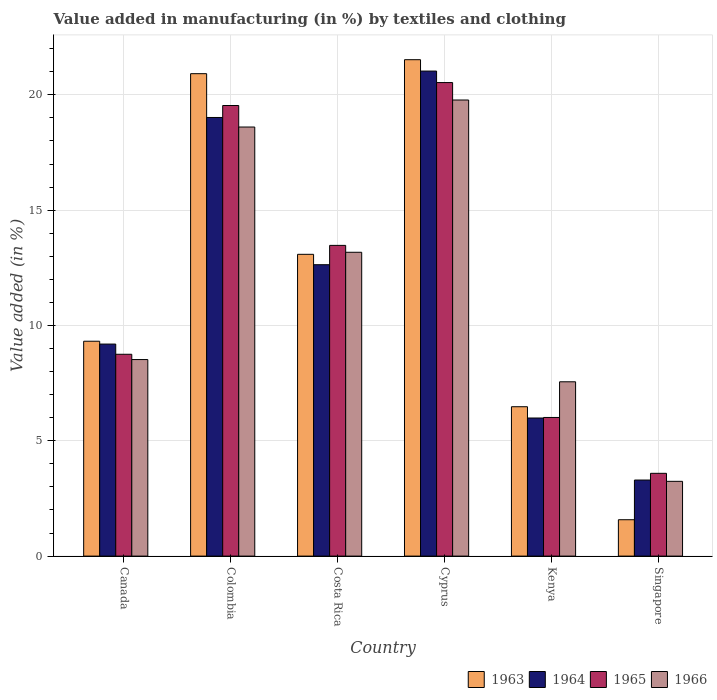Are the number of bars per tick equal to the number of legend labels?
Provide a succinct answer. Yes. In how many cases, is the number of bars for a given country not equal to the number of legend labels?
Your response must be concise. 0. What is the percentage of value added in manufacturing by textiles and clothing in 1964 in Canada?
Ensure brevity in your answer.  9.19. Across all countries, what is the maximum percentage of value added in manufacturing by textiles and clothing in 1964?
Provide a succinct answer. 21.03. Across all countries, what is the minimum percentage of value added in manufacturing by textiles and clothing in 1966?
Give a very brief answer. 3.24. In which country was the percentage of value added in manufacturing by textiles and clothing in 1964 maximum?
Provide a short and direct response. Cyprus. In which country was the percentage of value added in manufacturing by textiles and clothing in 1966 minimum?
Provide a succinct answer. Singapore. What is the total percentage of value added in manufacturing by textiles and clothing in 1963 in the graph?
Ensure brevity in your answer.  72.9. What is the difference between the percentage of value added in manufacturing by textiles and clothing in 1966 in Colombia and that in Costa Rica?
Your answer should be compact. 5.43. What is the difference between the percentage of value added in manufacturing by textiles and clothing in 1965 in Singapore and the percentage of value added in manufacturing by textiles and clothing in 1966 in Cyprus?
Your response must be concise. -16.19. What is the average percentage of value added in manufacturing by textiles and clothing in 1966 per country?
Your response must be concise. 11.81. What is the difference between the percentage of value added in manufacturing by textiles and clothing of/in 1963 and percentage of value added in manufacturing by textiles and clothing of/in 1965 in Canada?
Offer a very short reply. 0.57. What is the ratio of the percentage of value added in manufacturing by textiles and clothing in 1964 in Costa Rica to that in Kenya?
Keep it short and to the point. 2.11. What is the difference between the highest and the second highest percentage of value added in manufacturing by textiles and clothing in 1965?
Ensure brevity in your answer.  -0.99. What is the difference between the highest and the lowest percentage of value added in manufacturing by textiles and clothing in 1964?
Your answer should be very brief. 17.73. Is the sum of the percentage of value added in manufacturing by textiles and clothing in 1966 in Canada and Singapore greater than the maximum percentage of value added in manufacturing by textiles and clothing in 1964 across all countries?
Your answer should be very brief. No. Is it the case that in every country, the sum of the percentage of value added in manufacturing by textiles and clothing in 1963 and percentage of value added in manufacturing by textiles and clothing in 1964 is greater than the sum of percentage of value added in manufacturing by textiles and clothing in 1966 and percentage of value added in manufacturing by textiles and clothing in 1965?
Offer a very short reply. No. What does the 4th bar from the left in Canada represents?
Provide a succinct answer. 1966. What does the 1st bar from the right in Colombia represents?
Provide a short and direct response. 1966. Is it the case that in every country, the sum of the percentage of value added in manufacturing by textiles and clothing in 1966 and percentage of value added in manufacturing by textiles and clothing in 1965 is greater than the percentage of value added in manufacturing by textiles and clothing in 1964?
Keep it short and to the point. Yes. How many bars are there?
Your response must be concise. 24. What is the difference between two consecutive major ticks on the Y-axis?
Your answer should be very brief. 5. Does the graph contain grids?
Your response must be concise. Yes. What is the title of the graph?
Your answer should be compact. Value added in manufacturing (in %) by textiles and clothing. Does "1988" appear as one of the legend labels in the graph?
Offer a very short reply. No. What is the label or title of the X-axis?
Provide a short and direct response. Country. What is the label or title of the Y-axis?
Offer a terse response. Value added (in %). What is the Value added (in %) of 1963 in Canada?
Your answer should be compact. 9.32. What is the Value added (in %) of 1964 in Canada?
Ensure brevity in your answer.  9.19. What is the Value added (in %) of 1965 in Canada?
Give a very brief answer. 8.75. What is the Value added (in %) in 1966 in Canada?
Ensure brevity in your answer.  8.52. What is the Value added (in %) in 1963 in Colombia?
Make the answer very short. 20.92. What is the Value added (in %) in 1964 in Colombia?
Give a very brief answer. 19.02. What is the Value added (in %) in 1965 in Colombia?
Your response must be concise. 19.54. What is the Value added (in %) of 1966 in Colombia?
Give a very brief answer. 18.6. What is the Value added (in %) of 1963 in Costa Rica?
Your answer should be very brief. 13.08. What is the Value added (in %) in 1964 in Costa Rica?
Ensure brevity in your answer.  12.63. What is the Value added (in %) in 1965 in Costa Rica?
Provide a succinct answer. 13.47. What is the Value added (in %) in 1966 in Costa Rica?
Ensure brevity in your answer.  13.17. What is the Value added (in %) in 1963 in Cyprus?
Give a very brief answer. 21.52. What is the Value added (in %) in 1964 in Cyprus?
Give a very brief answer. 21.03. What is the Value added (in %) of 1965 in Cyprus?
Your answer should be very brief. 20.53. What is the Value added (in %) of 1966 in Cyprus?
Offer a terse response. 19.78. What is the Value added (in %) in 1963 in Kenya?
Keep it short and to the point. 6.48. What is the Value added (in %) of 1964 in Kenya?
Ensure brevity in your answer.  5.99. What is the Value added (in %) in 1965 in Kenya?
Offer a very short reply. 6.01. What is the Value added (in %) of 1966 in Kenya?
Offer a terse response. 7.56. What is the Value added (in %) of 1963 in Singapore?
Your answer should be very brief. 1.58. What is the Value added (in %) of 1964 in Singapore?
Offer a terse response. 3.3. What is the Value added (in %) of 1965 in Singapore?
Give a very brief answer. 3.59. What is the Value added (in %) of 1966 in Singapore?
Give a very brief answer. 3.24. Across all countries, what is the maximum Value added (in %) in 1963?
Make the answer very short. 21.52. Across all countries, what is the maximum Value added (in %) of 1964?
Offer a terse response. 21.03. Across all countries, what is the maximum Value added (in %) in 1965?
Provide a succinct answer. 20.53. Across all countries, what is the maximum Value added (in %) of 1966?
Your response must be concise. 19.78. Across all countries, what is the minimum Value added (in %) of 1963?
Make the answer very short. 1.58. Across all countries, what is the minimum Value added (in %) of 1964?
Offer a terse response. 3.3. Across all countries, what is the minimum Value added (in %) of 1965?
Give a very brief answer. 3.59. Across all countries, what is the minimum Value added (in %) of 1966?
Your response must be concise. 3.24. What is the total Value added (in %) of 1963 in the graph?
Make the answer very short. 72.9. What is the total Value added (in %) in 1964 in the graph?
Make the answer very short. 71.16. What is the total Value added (in %) of 1965 in the graph?
Give a very brief answer. 71.89. What is the total Value added (in %) of 1966 in the graph?
Provide a succinct answer. 70.87. What is the difference between the Value added (in %) of 1963 in Canada and that in Colombia?
Ensure brevity in your answer.  -11.6. What is the difference between the Value added (in %) of 1964 in Canada and that in Colombia?
Provide a succinct answer. -9.82. What is the difference between the Value added (in %) of 1965 in Canada and that in Colombia?
Provide a succinct answer. -10.79. What is the difference between the Value added (in %) of 1966 in Canada and that in Colombia?
Make the answer very short. -10.08. What is the difference between the Value added (in %) of 1963 in Canada and that in Costa Rica?
Keep it short and to the point. -3.77. What is the difference between the Value added (in %) in 1964 in Canada and that in Costa Rica?
Offer a terse response. -3.44. What is the difference between the Value added (in %) in 1965 in Canada and that in Costa Rica?
Keep it short and to the point. -4.72. What is the difference between the Value added (in %) in 1966 in Canada and that in Costa Rica?
Provide a short and direct response. -4.65. What is the difference between the Value added (in %) of 1963 in Canada and that in Cyprus?
Provide a succinct answer. -12.21. What is the difference between the Value added (in %) of 1964 in Canada and that in Cyprus?
Make the answer very short. -11.84. What is the difference between the Value added (in %) of 1965 in Canada and that in Cyprus?
Make the answer very short. -11.78. What is the difference between the Value added (in %) in 1966 in Canada and that in Cyprus?
Keep it short and to the point. -11.25. What is the difference between the Value added (in %) in 1963 in Canada and that in Kenya?
Provide a succinct answer. 2.84. What is the difference between the Value added (in %) in 1964 in Canada and that in Kenya?
Your answer should be compact. 3.21. What is the difference between the Value added (in %) of 1965 in Canada and that in Kenya?
Give a very brief answer. 2.74. What is the difference between the Value added (in %) of 1966 in Canada and that in Kenya?
Provide a succinct answer. 0.96. What is the difference between the Value added (in %) of 1963 in Canada and that in Singapore?
Provide a succinct answer. 7.74. What is the difference between the Value added (in %) in 1964 in Canada and that in Singapore?
Make the answer very short. 5.9. What is the difference between the Value added (in %) in 1965 in Canada and that in Singapore?
Provide a succinct answer. 5.16. What is the difference between the Value added (in %) in 1966 in Canada and that in Singapore?
Make the answer very short. 5.28. What is the difference between the Value added (in %) in 1963 in Colombia and that in Costa Rica?
Make the answer very short. 7.83. What is the difference between the Value added (in %) of 1964 in Colombia and that in Costa Rica?
Give a very brief answer. 6.38. What is the difference between the Value added (in %) in 1965 in Colombia and that in Costa Rica?
Provide a succinct answer. 6.06. What is the difference between the Value added (in %) of 1966 in Colombia and that in Costa Rica?
Your response must be concise. 5.43. What is the difference between the Value added (in %) in 1963 in Colombia and that in Cyprus?
Provide a succinct answer. -0.61. What is the difference between the Value added (in %) in 1964 in Colombia and that in Cyprus?
Provide a short and direct response. -2.01. What is the difference between the Value added (in %) of 1965 in Colombia and that in Cyprus?
Make the answer very short. -0.99. What is the difference between the Value added (in %) in 1966 in Colombia and that in Cyprus?
Keep it short and to the point. -1.17. What is the difference between the Value added (in %) in 1963 in Colombia and that in Kenya?
Give a very brief answer. 14.44. What is the difference between the Value added (in %) in 1964 in Colombia and that in Kenya?
Make the answer very short. 13.03. What is the difference between the Value added (in %) of 1965 in Colombia and that in Kenya?
Offer a terse response. 13.53. What is the difference between the Value added (in %) in 1966 in Colombia and that in Kenya?
Make the answer very short. 11.05. What is the difference between the Value added (in %) of 1963 in Colombia and that in Singapore?
Keep it short and to the point. 19.34. What is the difference between the Value added (in %) in 1964 in Colombia and that in Singapore?
Offer a very short reply. 15.72. What is the difference between the Value added (in %) in 1965 in Colombia and that in Singapore?
Your response must be concise. 15.95. What is the difference between the Value added (in %) in 1966 in Colombia and that in Singapore?
Your answer should be compact. 15.36. What is the difference between the Value added (in %) of 1963 in Costa Rica and that in Cyprus?
Offer a terse response. -8.44. What is the difference between the Value added (in %) in 1964 in Costa Rica and that in Cyprus?
Offer a very short reply. -8.4. What is the difference between the Value added (in %) in 1965 in Costa Rica and that in Cyprus?
Make the answer very short. -7.06. What is the difference between the Value added (in %) of 1966 in Costa Rica and that in Cyprus?
Offer a very short reply. -6.6. What is the difference between the Value added (in %) in 1963 in Costa Rica and that in Kenya?
Offer a terse response. 6.61. What is the difference between the Value added (in %) of 1964 in Costa Rica and that in Kenya?
Your answer should be compact. 6.65. What is the difference between the Value added (in %) of 1965 in Costa Rica and that in Kenya?
Give a very brief answer. 7.46. What is the difference between the Value added (in %) in 1966 in Costa Rica and that in Kenya?
Provide a succinct answer. 5.62. What is the difference between the Value added (in %) of 1963 in Costa Rica and that in Singapore?
Make the answer very short. 11.51. What is the difference between the Value added (in %) of 1964 in Costa Rica and that in Singapore?
Give a very brief answer. 9.34. What is the difference between the Value added (in %) of 1965 in Costa Rica and that in Singapore?
Your answer should be very brief. 9.88. What is the difference between the Value added (in %) of 1966 in Costa Rica and that in Singapore?
Provide a succinct answer. 9.93. What is the difference between the Value added (in %) in 1963 in Cyprus and that in Kenya?
Keep it short and to the point. 15.05. What is the difference between the Value added (in %) in 1964 in Cyprus and that in Kenya?
Your response must be concise. 15.04. What is the difference between the Value added (in %) in 1965 in Cyprus and that in Kenya?
Keep it short and to the point. 14.52. What is the difference between the Value added (in %) in 1966 in Cyprus and that in Kenya?
Make the answer very short. 12.22. What is the difference between the Value added (in %) in 1963 in Cyprus and that in Singapore?
Ensure brevity in your answer.  19.95. What is the difference between the Value added (in %) of 1964 in Cyprus and that in Singapore?
Keep it short and to the point. 17.73. What is the difference between the Value added (in %) in 1965 in Cyprus and that in Singapore?
Offer a very short reply. 16.94. What is the difference between the Value added (in %) in 1966 in Cyprus and that in Singapore?
Give a very brief answer. 16.53. What is the difference between the Value added (in %) of 1963 in Kenya and that in Singapore?
Give a very brief answer. 4.9. What is the difference between the Value added (in %) in 1964 in Kenya and that in Singapore?
Your response must be concise. 2.69. What is the difference between the Value added (in %) of 1965 in Kenya and that in Singapore?
Your response must be concise. 2.42. What is the difference between the Value added (in %) of 1966 in Kenya and that in Singapore?
Give a very brief answer. 4.32. What is the difference between the Value added (in %) in 1963 in Canada and the Value added (in %) in 1964 in Colombia?
Make the answer very short. -9.7. What is the difference between the Value added (in %) in 1963 in Canada and the Value added (in %) in 1965 in Colombia?
Offer a terse response. -10.22. What is the difference between the Value added (in %) in 1963 in Canada and the Value added (in %) in 1966 in Colombia?
Keep it short and to the point. -9.29. What is the difference between the Value added (in %) in 1964 in Canada and the Value added (in %) in 1965 in Colombia?
Your answer should be very brief. -10.34. What is the difference between the Value added (in %) in 1964 in Canada and the Value added (in %) in 1966 in Colombia?
Offer a very short reply. -9.41. What is the difference between the Value added (in %) of 1965 in Canada and the Value added (in %) of 1966 in Colombia?
Give a very brief answer. -9.85. What is the difference between the Value added (in %) of 1963 in Canada and the Value added (in %) of 1964 in Costa Rica?
Give a very brief answer. -3.32. What is the difference between the Value added (in %) in 1963 in Canada and the Value added (in %) in 1965 in Costa Rica?
Your response must be concise. -4.16. What is the difference between the Value added (in %) of 1963 in Canada and the Value added (in %) of 1966 in Costa Rica?
Your answer should be compact. -3.86. What is the difference between the Value added (in %) of 1964 in Canada and the Value added (in %) of 1965 in Costa Rica?
Provide a succinct answer. -4.28. What is the difference between the Value added (in %) of 1964 in Canada and the Value added (in %) of 1966 in Costa Rica?
Offer a very short reply. -3.98. What is the difference between the Value added (in %) of 1965 in Canada and the Value added (in %) of 1966 in Costa Rica?
Offer a very short reply. -4.42. What is the difference between the Value added (in %) of 1963 in Canada and the Value added (in %) of 1964 in Cyprus?
Provide a short and direct response. -11.71. What is the difference between the Value added (in %) in 1963 in Canada and the Value added (in %) in 1965 in Cyprus?
Offer a terse response. -11.21. What is the difference between the Value added (in %) in 1963 in Canada and the Value added (in %) in 1966 in Cyprus?
Provide a succinct answer. -10.46. What is the difference between the Value added (in %) of 1964 in Canada and the Value added (in %) of 1965 in Cyprus?
Offer a very short reply. -11.34. What is the difference between the Value added (in %) of 1964 in Canada and the Value added (in %) of 1966 in Cyprus?
Offer a terse response. -10.58. What is the difference between the Value added (in %) of 1965 in Canada and the Value added (in %) of 1966 in Cyprus?
Make the answer very short. -11.02. What is the difference between the Value added (in %) of 1963 in Canada and the Value added (in %) of 1964 in Kenya?
Provide a succinct answer. 3.33. What is the difference between the Value added (in %) in 1963 in Canada and the Value added (in %) in 1965 in Kenya?
Offer a terse response. 3.31. What is the difference between the Value added (in %) of 1963 in Canada and the Value added (in %) of 1966 in Kenya?
Your answer should be very brief. 1.76. What is the difference between the Value added (in %) of 1964 in Canada and the Value added (in %) of 1965 in Kenya?
Your answer should be compact. 3.18. What is the difference between the Value added (in %) of 1964 in Canada and the Value added (in %) of 1966 in Kenya?
Provide a short and direct response. 1.64. What is the difference between the Value added (in %) of 1965 in Canada and the Value added (in %) of 1966 in Kenya?
Your response must be concise. 1.19. What is the difference between the Value added (in %) in 1963 in Canada and the Value added (in %) in 1964 in Singapore?
Offer a very short reply. 6.02. What is the difference between the Value added (in %) of 1963 in Canada and the Value added (in %) of 1965 in Singapore?
Make the answer very short. 5.73. What is the difference between the Value added (in %) in 1963 in Canada and the Value added (in %) in 1966 in Singapore?
Ensure brevity in your answer.  6.08. What is the difference between the Value added (in %) in 1964 in Canada and the Value added (in %) in 1965 in Singapore?
Make the answer very short. 5.6. What is the difference between the Value added (in %) of 1964 in Canada and the Value added (in %) of 1966 in Singapore?
Ensure brevity in your answer.  5.95. What is the difference between the Value added (in %) of 1965 in Canada and the Value added (in %) of 1966 in Singapore?
Offer a very short reply. 5.51. What is the difference between the Value added (in %) of 1963 in Colombia and the Value added (in %) of 1964 in Costa Rica?
Offer a terse response. 8.28. What is the difference between the Value added (in %) of 1963 in Colombia and the Value added (in %) of 1965 in Costa Rica?
Your response must be concise. 7.44. What is the difference between the Value added (in %) in 1963 in Colombia and the Value added (in %) in 1966 in Costa Rica?
Your answer should be very brief. 7.74. What is the difference between the Value added (in %) of 1964 in Colombia and the Value added (in %) of 1965 in Costa Rica?
Keep it short and to the point. 5.55. What is the difference between the Value added (in %) of 1964 in Colombia and the Value added (in %) of 1966 in Costa Rica?
Offer a terse response. 5.84. What is the difference between the Value added (in %) in 1965 in Colombia and the Value added (in %) in 1966 in Costa Rica?
Ensure brevity in your answer.  6.36. What is the difference between the Value added (in %) of 1963 in Colombia and the Value added (in %) of 1964 in Cyprus?
Offer a terse response. -0.11. What is the difference between the Value added (in %) of 1963 in Colombia and the Value added (in %) of 1965 in Cyprus?
Provide a succinct answer. 0.39. What is the difference between the Value added (in %) of 1963 in Colombia and the Value added (in %) of 1966 in Cyprus?
Make the answer very short. 1.14. What is the difference between the Value added (in %) of 1964 in Colombia and the Value added (in %) of 1965 in Cyprus?
Offer a terse response. -1.51. What is the difference between the Value added (in %) in 1964 in Colombia and the Value added (in %) in 1966 in Cyprus?
Provide a succinct answer. -0.76. What is the difference between the Value added (in %) of 1965 in Colombia and the Value added (in %) of 1966 in Cyprus?
Provide a short and direct response. -0.24. What is the difference between the Value added (in %) of 1963 in Colombia and the Value added (in %) of 1964 in Kenya?
Provide a succinct answer. 14.93. What is the difference between the Value added (in %) of 1963 in Colombia and the Value added (in %) of 1965 in Kenya?
Keep it short and to the point. 14.91. What is the difference between the Value added (in %) in 1963 in Colombia and the Value added (in %) in 1966 in Kenya?
Keep it short and to the point. 13.36. What is the difference between the Value added (in %) of 1964 in Colombia and the Value added (in %) of 1965 in Kenya?
Ensure brevity in your answer.  13.01. What is the difference between the Value added (in %) of 1964 in Colombia and the Value added (in %) of 1966 in Kenya?
Ensure brevity in your answer.  11.46. What is the difference between the Value added (in %) in 1965 in Colombia and the Value added (in %) in 1966 in Kenya?
Provide a short and direct response. 11.98. What is the difference between the Value added (in %) in 1963 in Colombia and the Value added (in %) in 1964 in Singapore?
Keep it short and to the point. 17.62. What is the difference between the Value added (in %) in 1963 in Colombia and the Value added (in %) in 1965 in Singapore?
Provide a succinct answer. 17.33. What is the difference between the Value added (in %) of 1963 in Colombia and the Value added (in %) of 1966 in Singapore?
Your answer should be very brief. 17.68. What is the difference between the Value added (in %) in 1964 in Colombia and the Value added (in %) in 1965 in Singapore?
Keep it short and to the point. 15.43. What is the difference between the Value added (in %) of 1964 in Colombia and the Value added (in %) of 1966 in Singapore?
Offer a terse response. 15.78. What is the difference between the Value added (in %) of 1965 in Colombia and the Value added (in %) of 1966 in Singapore?
Ensure brevity in your answer.  16.3. What is the difference between the Value added (in %) in 1963 in Costa Rica and the Value added (in %) in 1964 in Cyprus?
Make the answer very short. -7.95. What is the difference between the Value added (in %) of 1963 in Costa Rica and the Value added (in %) of 1965 in Cyprus?
Your answer should be very brief. -7.45. What is the difference between the Value added (in %) in 1963 in Costa Rica and the Value added (in %) in 1966 in Cyprus?
Ensure brevity in your answer.  -6.69. What is the difference between the Value added (in %) of 1964 in Costa Rica and the Value added (in %) of 1965 in Cyprus?
Your response must be concise. -7.9. What is the difference between the Value added (in %) in 1964 in Costa Rica and the Value added (in %) in 1966 in Cyprus?
Your response must be concise. -7.14. What is the difference between the Value added (in %) of 1965 in Costa Rica and the Value added (in %) of 1966 in Cyprus?
Give a very brief answer. -6.3. What is the difference between the Value added (in %) in 1963 in Costa Rica and the Value added (in %) in 1964 in Kenya?
Your answer should be very brief. 7.1. What is the difference between the Value added (in %) in 1963 in Costa Rica and the Value added (in %) in 1965 in Kenya?
Provide a short and direct response. 7.07. What is the difference between the Value added (in %) of 1963 in Costa Rica and the Value added (in %) of 1966 in Kenya?
Keep it short and to the point. 5.53. What is the difference between the Value added (in %) in 1964 in Costa Rica and the Value added (in %) in 1965 in Kenya?
Keep it short and to the point. 6.62. What is the difference between the Value added (in %) of 1964 in Costa Rica and the Value added (in %) of 1966 in Kenya?
Provide a short and direct response. 5.08. What is the difference between the Value added (in %) of 1965 in Costa Rica and the Value added (in %) of 1966 in Kenya?
Give a very brief answer. 5.91. What is the difference between the Value added (in %) of 1963 in Costa Rica and the Value added (in %) of 1964 in Singapore?
Your response must be concise. 9.79. What is the difference between the Value added (in %) in 1963 in Costa Rica and the Value added (in %) in 1965 in Singapore?
Your answer should be very brief. 9.5. What is the difference between the Value added (in %) in 1963 in Costa Rica and the Value added (in %) in 1966 in Singapore?
Offer a very short reply. 9.84. What is the difference between the Value added (in %) in 1964 in Costa Rica and the Value added (in %) in 1965 in Singapore?
Offer a very short reply. 9.04. What is the difference between the Value added (in %) of 1964 in Costa Rica and the Value added (in %) of 1966 in Singapore?
Offer a very short reply. 9.39. What is the difference between the Value added (in %) of 1965 in Costa Rica and the Value added (in %) of 1966 in Singapore?
Keep it short and to the point. 10.23. What is the difference between the Value added (in %) in 1963 in Cyprus and the Value added (in %) in 1964 in Kenya?
Give a very brief answer. 15.54. What is the difference between the Value added (in %) in 1963 in Cyprus and the Value added (in %) in 1965 in Kenya?
Offer a very short reply. 15.51. What is the difference between the Value added (in %) of 1963 in Cyprus and the Value added (in %) of 1966 in Kenya?
Provide a succinct answer. 13.97. What is the difference between the Value added (in %) of 1964 in Cyprus and the Value added (in %) of 1965 in Kenya?
Provide a short and direct response. 15.02. What is the difference between the Value added (in %) of 1964 in Cyprus and the Value added (in %) of 1966 in Kenya?
Your answer should be compact. 13.47. What is the difference between the Value added (in %) of 1965 in Cyprus and the Value added (in %) of 1966 in Kenya?
Give a very brief answer. 12.97. What is the difference between the Value added (in %) in 1963 in Cyprus and the Value added (in %) in 1964 in Singapore?
Ensure brevity in your answer.  18.23. What is the difference between the Value added (in %) in 1963 in Cyprus and the Value added (in %) in 1965 in Singapore?
Keep it short and to the point. 17.93. What is the difference between the Value added (in %) in 1963 in Cyprus and the Value added (in %) in 1966 in Singapore?
Offer a terse response. 18.28. What is the difference between the Value added (in %) of 1964 in Cyprus and the Value added (in %) of 1965 in Singapore?
Give a very brief answer. 17.44. What is the difference between the Value added (in %) in 1964 in Cyprus and the Value added (in %) in 1966 in Singapore?
Ensure brevity in your answer.  17.79. What is the difference between the Value added (in %) in 1965 in Cyprus and the Value added (in %) in 1966 in Singapore?
Your response must be concise. 17.29. What is the difference between the Value added (in %) of 1963 in Kenya and the Value added (in %) of 1964 in Singapore?
Offer a very short reply. 3.18. What is the difference between the Value added (in %) in 1963 in Kenya and the Value added (in %) in 1965 in Singapore?
Your answer should be very brief. 2.89. What is the difference between the Value added (in %) of 1963 in Kenya and the Value added (in %) of 1966 in Singapore?
Provide a short and direct response. 3.24. What is the difference between the Value added (in %) in 1964 in Kenya and the Value added (in %) in 1965 in Singapore?
Offer a terse response. 2.4. What is the difference between the Value added (in %) in 1964 in Kenya and the Value added (in %) in 1966 in Singapore?
Offer a very short reply. 2.75. What is the difference between the Value added (in %) of 1965 in Kenya and the Value added (in %) of 1966 in Singapore?
Ensure brevity in your answer.  2.77. What is the average Value added (in %) in 1963 per country?
Your answer should be compact. 12.15. What is the average Value added (in %) in 1964 per country?
Offer a very short reply. 11.86. What is the average Value added (in %) of 1965 per country?
Provide a short and direct response. 11.98. What is the average Value added (in %) of 1966 per country?
Give a very brief answer. 11.81. What is the difference between the Value added (in %) in 1963 and Value added (in %) in 1964 in Canada?
Provide a succinct answer. 0.12. What is the difference between the Value added (in %) of 1963 and Value added (in %) of 1965 in Canada?
Your answer should be very brief. 0.57. What is the difference between the Value added (in %) of 1963 and Value added (in %) of 1966 in Canada?
Give a very brief answer. 0.8. What is the difference between the Value added (in %) in 1964 and Value added (in %) in 1965 in Canada?
Your answer should be very brief. 0.44. What is the difference between the Value added (in %) in 1964 and Value added (in %) in 1966 in Canada?
Ensure brevity in your answer.  0.67. What is the difference between the Value added (in %) in 1965 and Value added (in %) in 1966 in Canada?
Offer a terse response. 0.23. What is the difference between the Value added (in %) of 1963 and Value added (in %) of 1964 in Colombia?
Your response must be concise. 1.9. What is the difference between the Value added (in %) in 1963 and Value added (in %) in 1965 in Colombia?
Your answer should be compact. 1.38. What is the difference between the Value added (in %) in 1963 and Value added (in %) in 1966 in Colombia?
Your answer should be compact. 2.31. What is the difference between the Value added (in %) of 1964 and Value added (in %) of 1965 in Colombia?
Ensure brevity in your answer.  -0.52. What is the difference between the Value added (in %) of 1964 and Value added (in %) of 1966 in Colombia?
Make the answer very short. 0.41. What is the difference between the Value added (in %) in 1965 and Value added (in %) in 1966 in Colombia?
Offer a very short reply. 0.93. What is the difference between the Value added (in %) in 1963 and Value added (in %) in 1964 in Costa Rica?
Make the answer very short. 0.45. What is the difference between the Value added (in %) of 1963 and Value added (in %) of 1965 in Costa Rica?
Provide a succinct answer. -0.39. What is the difference between the Value added (in %) in 1963 and Value added (in %) in 1966 in Costa Rica?
Provide a short and direct response. -0.09. What is the difference between the Value added (in %) of 1964 and Value added (in %) of 1965 in Costa Rica?
Offer a terse response. -0.84. What is the difference between the Value added (in %) of 1964 and Value added (in %) of 1966 in Costa Rica?
Provide a short and direct response. -0.54. What is the difference between the Value added (in %) of 1965 and Value added (in %) of 1966 in Costa Rica?
Provide a short and direct response. 0.3. What is the difference between the Value added (in %) in 1963 and Value added (in %) in 1964 in Cyprus?
Your answer should be compact. 0.49. What is the difference between the Value added (in %) in 1963 and Value added (in %) in 1966 in Cyprus?
Provide a short and direct response. 1.75. What is the difference between the Value added (in %) in 1964 and Value added (in %) in 1965 in Cyprus?
Your answer should be very brief. 0.5. What is the difference between the Value added (in %) of 1964 and Value added (in %) of 1966 in Cyprus?
Offer a terse response. 1.25. What is the difference between the Value added (in %) in 1965 and Value added (in %) in 1966 in Cyprus?
Your response must be concise. 0.76. What is the difference between the Value added (in %) of 1963 and Value added (in %) of 1964 in Kenya?
Give a very brief answer. 0.49. What is the difference between the Value added (in %) of 1963 and Value added (in %) of 1965 in Kenya?
Offer a terse response. 0.47. What is the difference between the Value added (in %) of 1963 and Value added (in %) of 1966 in Kenya?
Provide a succinct answer. -1.08. What is the difference between the Value added (in %) in 1964 and Value added (in %) in 1965 in Kenya?
Your answer should be compact. -0.02. What is the difference between the Value added (in %) in 1964 and Value added (in %) in 1966 in Kenya?
Ensure brevity in your answer.  -1.57. What is the difference between the Value added (in %) in 1965 and Value added (in %) in 1966 in Kenya?
Provide a short and direct response. -1.55. What is the difference between the Value added (in %) in 1963 and Value added (in %) in 1964 in Singapore?
Provide a succinct answer. -1.72. What is the difference between the Value added (in %) of 1963 and Value added (in %) of 1965 in Singapore?
Make the answer very short. -2.01. What is the difference between the Value added (in %) in 1963 and Value added (in %) in 1966 in Singapore?
Offer a very short reply. -1.66. What is the difference between the Value added (in %) of 1964 and Value added (in %) of 1965 in Singapore?
Offer a terse response. -0.29. What is the difference between the Value added (in %) of 1964 and Value added (in %) of 1966 in Singapore?
Keep it short and to the point. 0.06. What is the difference between the Value added (in %) in 1965 and Value added (in %) in 1966 in Singapore?
Your answer should be very brief. 0.35. What is the ratio of the Value added (in %) in 1963 in Canada to that in Colombia?
Offer a terse response. 0.45. What is the ratio of the Value added (in %) in 1964 in Canada to that in Colombia?
Offer a terse response. 0.48. What is the ratio of the Value added (in %) in 1965 in Canada to that in Colombia?
Ensure brevity in your answer.  0.45. What is the ratio of the Value added (in %) of 1966 in Canada to that in Colombia?
Make the answer very short. 0.46. What is the ratio of the Value added (in %) of 1963 in Canada to that in Costa Rica?
Provide a short and direct response. 0.71. What is the ratio of the Value added (in %) of 1964 in Canada to that in Costa Rica?
Your response must be concise. 0.73. What is the ratio of the Value added (in %) of 1965 in Canada to that in Costa Rica?
Offer a very short reply. 0.65. What is the ratio of the Value added (in %) in 1966 in Canada to that in Costa Rica?
Your response must be concise. 0.65. What is the ratio of the Value added (in %) in 1963 in Canada to that in Cyprus?
Offer a very short reply. 0.43. What is the ratio of the Value added (in %) in 1964 in Canada to that in Cyprus?
Make the answer very short. 0.44. What is the ratio of the Value added (in %) in 1965 in Canada to that in Cyprus?
Your response must be concise. 0.43. What is the ratio of the Value added (in %) of 1966 in Canada to that in Cyprus?
Provide a short and direct response. 0.43. What is the ratio of the Value added (in %) of 1963 in Canada to that in Kenya?
Your answer should be compact. 1.44. What is the ratio of the Value added (in %) in 1964 in Canada to that in Kenya?
Your response must be concise. 1.54. What is the ratio of the Value added (in %) of 1965 in Canada to that in Kenya?
Provide a short and direct response. 1.46. What is the ratio of the Value added (in %) in 1966 in Canada to that in Kenya?
Offer a very short reply. 1.13. What is the ratio of the Value added (in %) in 1963 in Canada to that in Singapore?
Ensure brevity in your answer.  5.91. What is the ratio of the Value added (in %) in 1964 in Canada to that in Singapore?
Make the answer very short. 2.79. What is the ratio of the Value added (in %) in 1965 in Canada to that in Singapore?
Provide a succinct answer. 2.44. What is the ratio of the Value added (in %) of 1966 in Canada to that in Singapore?
Offer a terse response. 2.63. What is the ratio of the Value added (in %) in 1963 in Colombia to that in Costa Rica?
Your answer should be compact. 1.6. What is the ratio of the Value added (in %) in 1964 in Colombia to that in Costa Rica?
Your answer should be compact. 1.51. What is the ratio of the Value added (in %) of 1965 in Colombia to that in Costa Rica?
Give a very brief answer. 1.45. What is the ratio of the Value added (in %) of 1966 in Colombia to that in Costa Rica?
Offer a very short reply. 1.41. What is the ratio of the Value added (in %) of 1963 in Colombia to that in Cyprus?
Your response must be concise. 0.97. What is the ratio of the Value added (in %) of 1964 in Colombia to that in Cyprus?
Provide a succinct answer. 0.9. What is the ratio of the Value added (in %) in 1965 in Colombia to that in Cyprus?
Keep it short and to the point. 0.95. What is the ratio of the Value added (in %) of 1966 in Colombia to that in Cyprus?
Your response must be concise. 0.94. What is the ratio of the Value added (in %) of 1963 in Colombia to that in Kenya?
Make the answer very short. 3.23. What is the ratio of the Value added (in %) of 1964 in Colombia to that in Kenya?
Provide a succinct answer. 3.18. What is the ratio of the Value added (in %) of 1965 in Colombia to that in Kenya?
Keep it short and to the point. 3.25. What is the ratio of the Value added (in %) of 1966 in Colombia to that in Kenya?
Offer a terse response. 2.46. What is the ratio of the Value added (in %) in 1963 in Colombia to that in Singapore?
Offer a very short reply. 13.26. What is the ratio of the Value added (in %) in 1964 in Colombia to that in Singapore?
Your answer should be compact. 5.77. What is the ratio of the Value added (in %) of 1965 in Colombia to that in Singapore?
Offer a very short reply. 5.44. What is the ratio of the Value added (in %) of 1966 in Colombia to that in Singapore?
Provide a succinct answer. 5.74. What is the ratio of the Value added (in %) of 1963 in Costa Rica to that in Cyprus?
Offer a very short reply. 0.61. What is the ratio of the Value added (in %) of 1964 in Costa Rica to that in Cyprus?
Give a very brief answer. 0.6. What is the ratio of the Value added (in %) in 1965 in Costa Rica to that in Cyprus?
Keep it short and to the point. 0.66. What is the ratio of the Value added (in %) of 1966 in Costa Rica to that in Cyprus?
Your response must be concise. 0.67. What is the ratio of the Value added (in %) in 1963 in Costa Rica to that in Kenya?
Ensure brevity in your answer.  2.02. What is the ratio of the Value added (in %) in 1964 in Costa Rica to that in Kenya?
Ensure brevity in your answer.  2.11. What is the ratio of the Value added (in %) of 1965 in Costa Rica to that in Kenya?
Provide a short and direct response. 2.24. What is the ratio of the Value added (in %) in 1966 in Costa Rica to that in Kenya?
Your answer should be very brief. 1.74. What is the ratio of the Value added (in %) in 1963 in Costa Rica to that in Singapore?
Provide a short and direct response. 8.3. What is the ratio of the Value added (in %) in 1964 in Costa Rica to that in Singapore?
Give a very brief answer. 3.83. What is the ratio of the Value added (in %) of 1965 in Costa Rica to that in Singapore?
Your response must be concise. 3.75. What is the ratio of the Value added (in %) of 1966 in Costa Rica to that in Singapore?
Your response must be concise. 4.06. What is the ratio of the Value added (in %) of 1963 in Cyprus to that in Kenya?
Give a very brief answer. 3.32. What is the ratio of the Value added (in %) of 1964 in Cyprus to that in Kenya?
Your answer should be compact. 3.51. What is the ratio of the Value added (in %) of 1965 in Cyprus to that in Kenya?
Keep it short and to the point. 3.42. What is the ratio of the Value added (in %) in 1966 in Cyprus to that in Kenya?
Your response must be concise. 2.62. What is the ratio of the Value added (in %) of 1963 in Cyprus to that in Singapore?
Make the answer very short. 13.65. What is the ratio of the Value added (in %) in 1964 in Cyprus to that in Singapore?
Offer a terse response. 6.38. What is the ratio of the Value added (in %) in 1965 in Cyprus to that in Singapore?
Provide a short and direct response. 5.72. What is the ratio of the Value added (in %) of 1966 in Cyprus to that in Singapore?
Provide a succinct answer. 6.1. What is the ratio of the Value added (in %) of 1963 in Kenya to that in Singapore?
Keep it short and to the point. 4.11. What is the ratio of the Value added (in %) of 1964 in Kenya to that in Singapore?
Your response must be concise. 1.82. What is the ratio of the Value added (in %) of 1965 in Kenya to that in Singapore?
Provide a short and direct response. 1.67. What is the ratio of the Value added (in %) in 1966 in Kenya to that in Singapore?
Keep it short and to the point. 2.33. What is the difference between the highest and the second highest Value added (in %) in 1963?
Offer a terse response. 0.61. What is the difference between the highest and the second highest Value added (in %) in 1964?
Provide a succinct answer. 2.01. What is the difference between the highest and the second highest Value added (in %) in 1966?
Keep it short and to the point. 1.17. What is the difference between the highest and the lowest Value added (in %) of 1963?
Offer a terse response. 19.95. What is the difference between the highest and the lowest Value added (in %) in 1964?
Ensure brevity in your answer.  17.73. What is the difference between the highest and the lowest Value added (in %) in 1965?
Offer a very short reply. 16.94. What is the difference between the highest and the lowest Value added (in %) in 1966?
Keep it short and to the point. 16.53. 